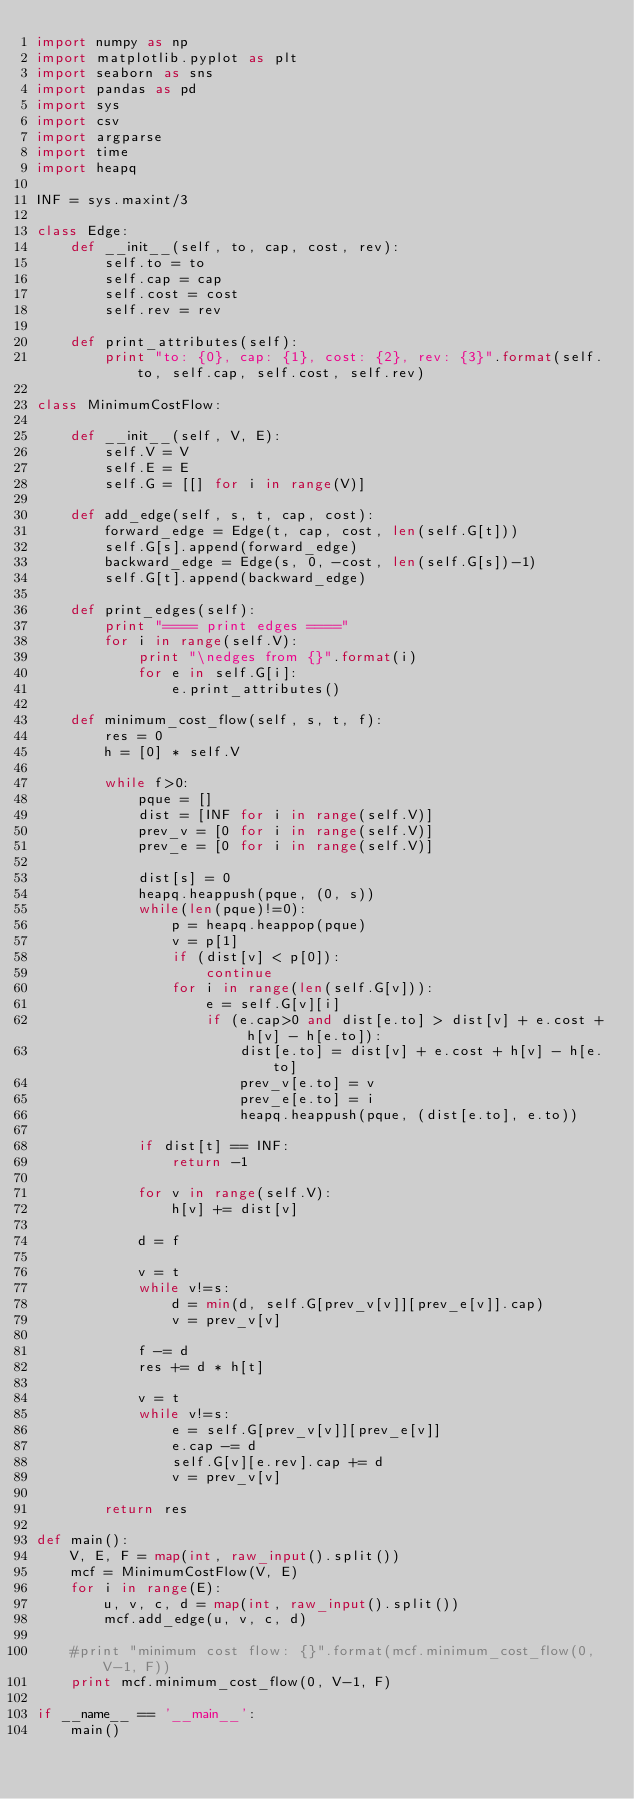Convert code to text. <code><loc_0><loc_0><loc_500><loc_500><_Python_>import numpy as np
import matplotlib.pyplot as plt
import seaborn as sns
import pandas as pd
import sys
import csv
import argparse
import time
import heapq

INF = sys.maxint/3

class Edge:
    def __init__(self, to, cap, cost, rev):
        self.to = to
        self.cap = cap
        self.cost = cost
        self.rev = rev

    def print_attributes(self):
        print "to: {0}, cap: {1}, cost: {2}, rev: {3}".format(self.to, self.cap, self.cost, self.rev)

class MinimumCostFlow:

    def __init__(self, V, E):
        self.V = V
        self.E = E
        self.G = [[] for i in range(V)]

    def add_edge(self, s, t, cap, cost):
        forward_edge = Edge(t, cap, cost, len(self.G[t]))
        self.G[s].append(forward_edge)
        backward_edge = Edge(s, 0, -cost, len(self.G[s])-1)
        self.G[t].append(backward_edge)

    def print_edges(self):
        print "==== print edges ===="
        for i in range(self.V):
            print "\nedges from {}".format(i)
            for e in self.G[i]:
                e.print_attributes()

    def minimum_cost_flow(self, s, t, f):
        res = 0
        h = [0] * self.V

        while f>0:
            pque = []
            dist = [INF for i in range(self.V)]
            prev_v = [0 for i in range(self.V)]
            prev_e = [0 for i in range(self.V)]

            dist[s] = 0
            heapq.heappush(pque, (0, s))
            while(len(pque)!=0):
                p = heapq.heappop(pque)
                v = p[1]
                if (dist[v] < p[0]):
                    continue
                for i in range(len(self.G[v])):
                    e = self.G[v][i]
                    if (e.cap>0 and dist[e.to] > dist[v] + e.cost + h[v] - h[e.to]):
                        dist[e.to] = dist[v] + e.cost + h[v] - h[e.to]
                        prev_v[e.to] = v
                        prev_e[e.to] = i
                        heapq.heappush(pque, (dist[e.to], e.to))

            if dist[t] == INF:
                return -1

            for v in range(self.V):
                h[v] += dist[v]

            d = f

            v = t
            while v!=s:
                d = min(d, self.G[prev_v[v]][prev_e[v]].cap)
                v = prev_v[v]

            f -= d
            res += d * h[t]

            v = t
            while v!=s:
                e = self.G[prev_v[v]][prev_e[v]]
                e.cap -= d
                self.G[v][e.rev].cap += d
                v = prev_v[v]

        return res

def main():
    V, E, F = map(int, raw_input().split())
    mcf = MinimumCostFlow(V, E)
    for i in range(E):
        u, v, c, d = map(int, raw_input().split())
        mcf.add_edge(u, v, c, d)

    #print "minimum cost flow: {}".format(mcf.minimum_cost_flow(0, V-1, F))
    print mcf.minimum_cost_flow(0, V-1, F)

if __name__ == '__main__':
    main()
</code> 